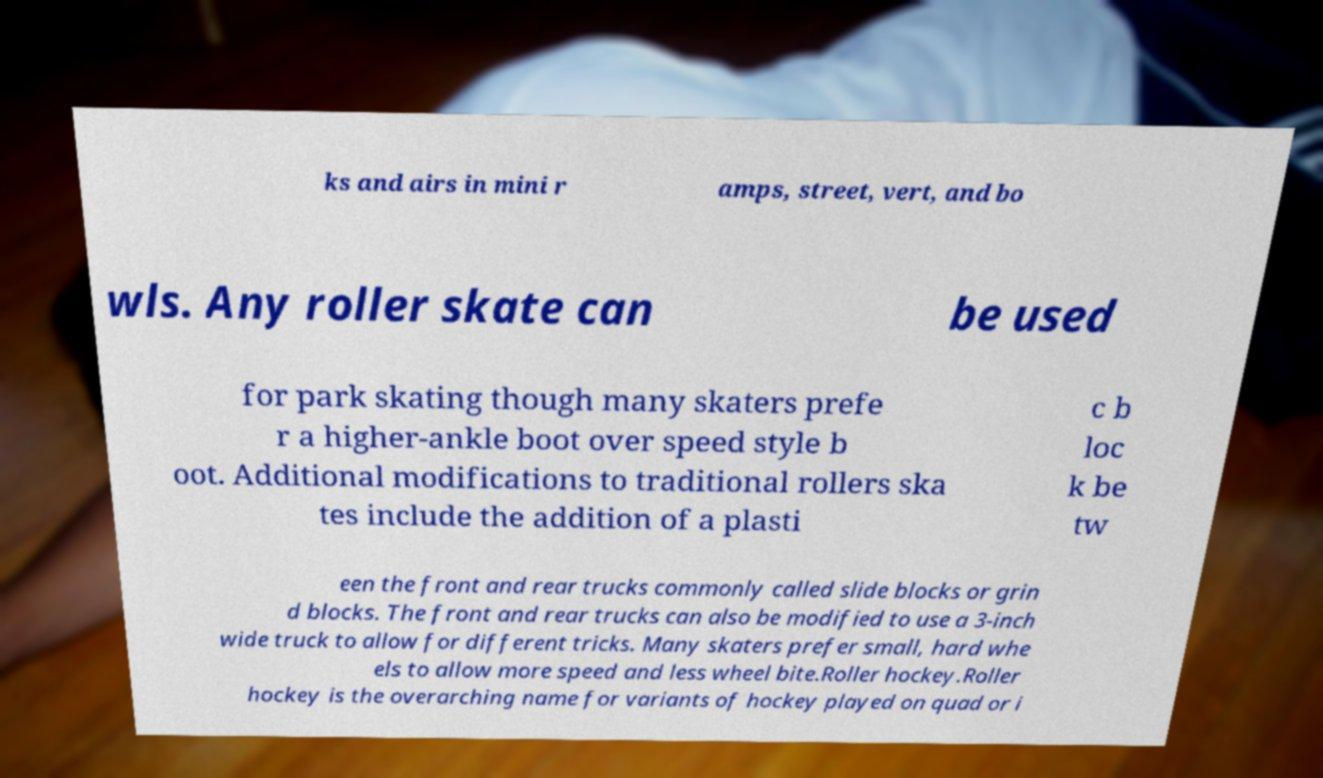What messages or text are displayed in this image? I need them in a readable, typed format. ks and airs in mini r amps, street, vert, and bo wls. Any roller skate can be used for park skating though many skaters prefe r a higher-ankle boot over speed style b oot. Additional modifications to traditional rollers ska tes include the addition of a plasti c b loc k be tw een the front and rear trucks commonly called slide blocks or grin d blocks. The front and rear trucks can also be modified to use a 3-inch wide truck to allow for different tricks. Many skaters prefer small, hard whe els to allow more speed and less wheel bite.Roller hockey.Roller hockey is the overarching name for variants of hockey played on quad or i 